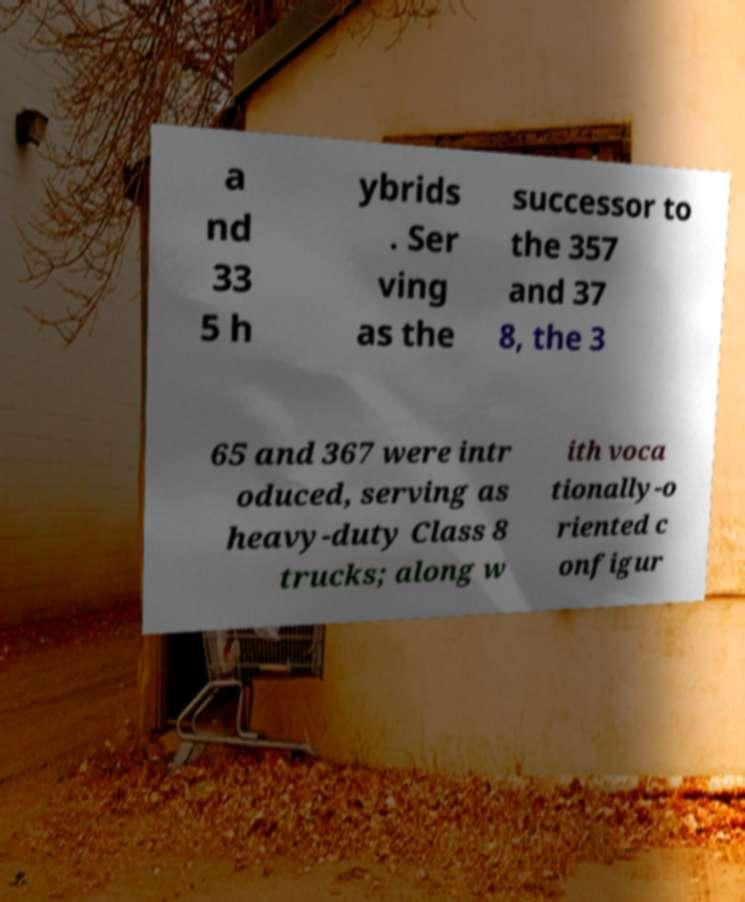Could you extract and type out the text from this image? a nd 33 5 h ybrids . Ser ving as the successor to the 357 and 37 8, the 3 65 and 367 were intr oduced, serving as heavy-duty Class 8 trucks; along w ith voca tionally-o riented c onfigur 